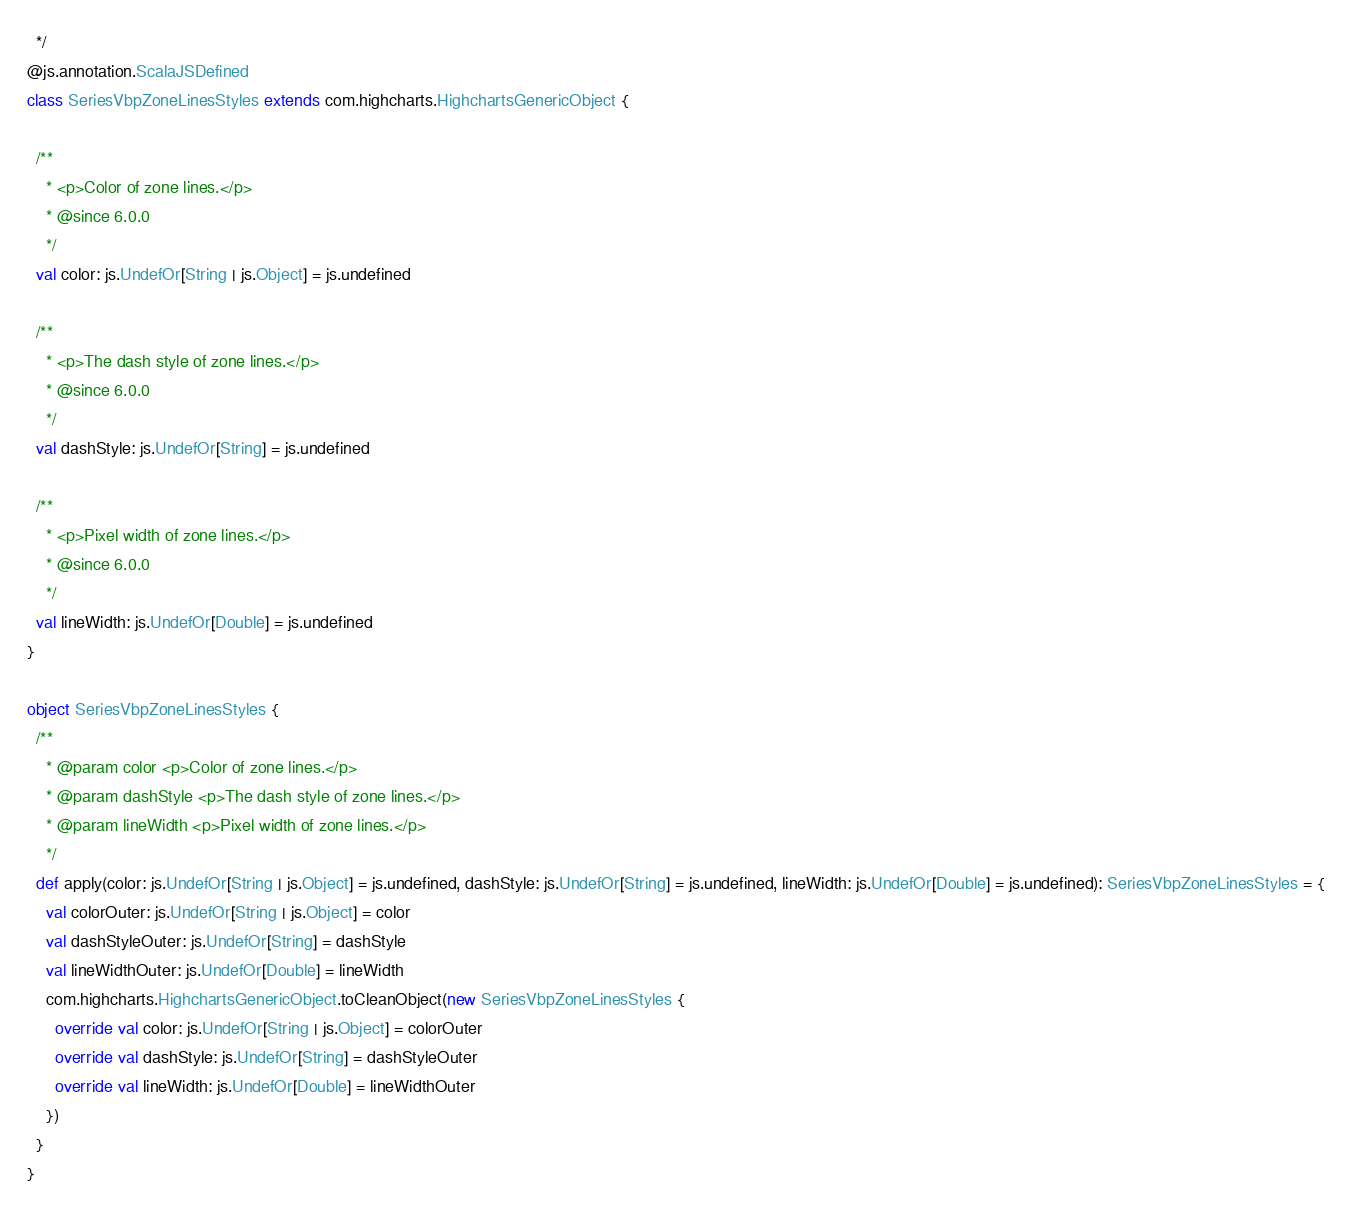Convert code to text. <code><loc_0><loc_0><loc_500><loc_500><_Scala_>  */
@js.annotation.ScalaJSDefined
class SeriesVbpZoneLinesStyles extends com.highcharts.HighchartsGenericObject {

  /**
    * <p>Color of zone lines.</p>
    * @since 6.0.0
    */
  val color: js.UndefOr[String | js.Object] = js.undefined

  /**
    * <p>The dash style of zone lines.</p>
    * @since 6.0.0
    */
  val dashStyle: js.UndefOr[String] = js.undefined

  /**
    * <p>Pixel width of zone lines.</p>
    * @since 6.0.0
    */
  val lineWidth: js.UndefOr[Double] = js.undefined
}

object SeriesVbpZoneLinesStyles {
  /**
    * @param color <p>Color of zone lines.</p>
    * @param dashStyle <p>The dash style of zone lines.</p>
    * @param lineWidth <p>Pixel width of zone lines.</p>
    */
  def apply(color: js.UndefOr[String | js.Object] = js.undefined, dashStyle: js.UndefOr[String] = js.undefined, lineWidth: js.UndefOr[Double] = js.undefined): SeriesVbpZoneLinesStyles = {
    val colorOuter: js.UndefOr[String | js.Object] = color
    val dashStyleOuter: js.UndefOr[String] = dashStyle
    val lineWidthOuter: js.UndefOr[Double] = lineWidth
    com.highcharts.HighchartsGenericObject.toCleanObject(new SeriesVbpZoneLinesStyles {
      override val color: js.UndefOr[String | js.Object] = colorOuter
      override val dashStyle: js.UndefOr[String] = dashStyleOuter
      override val lineWidth: js.UndefOr[Double] = lineWidthOuter
    })
  }
}
</code> 